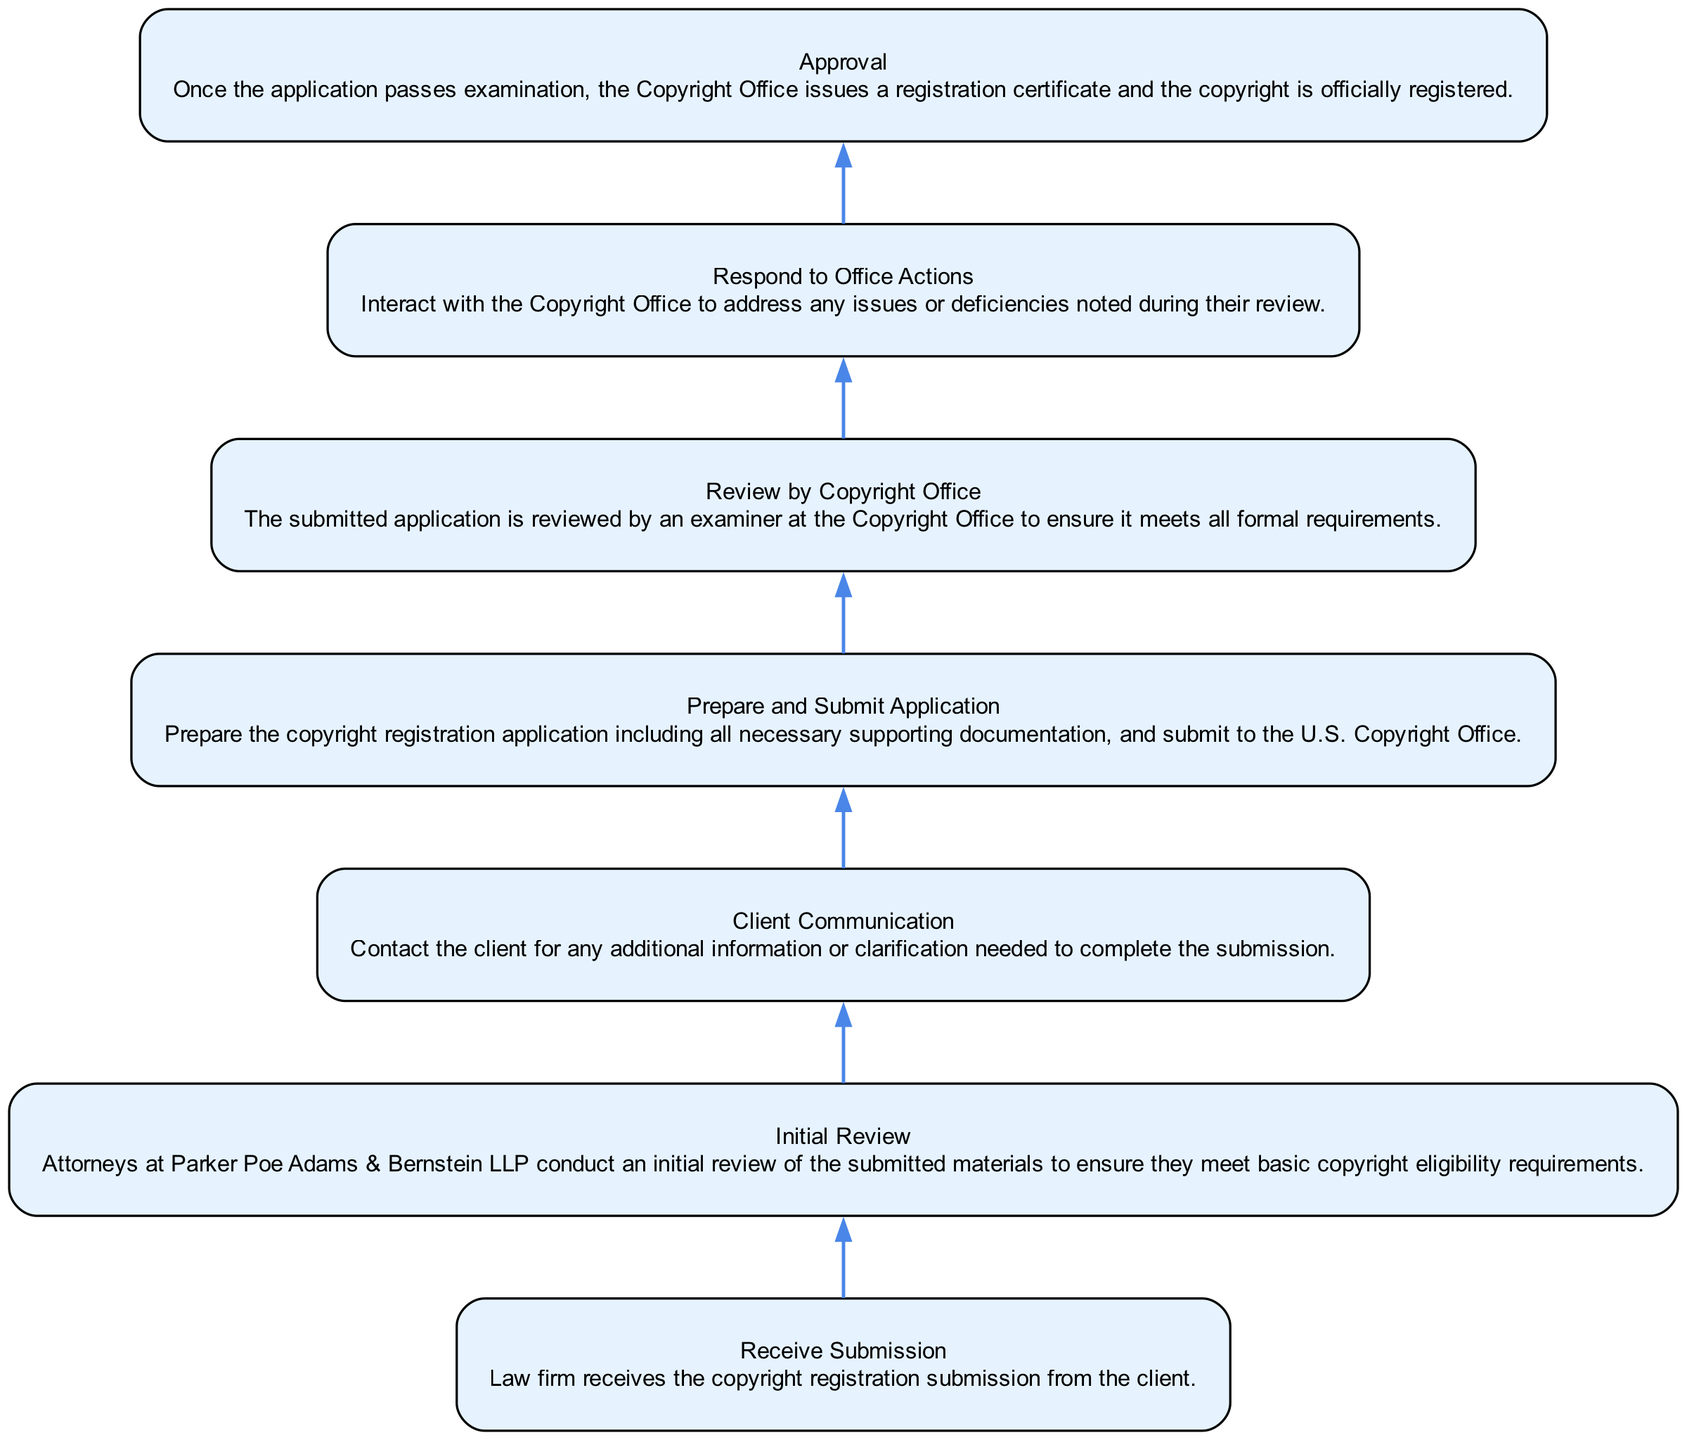What is the first step in the workflow? The first step in the workflow is labeled "Receive Submission" which indicates that the law firm has received the copyright registration submission from the client.
Answer: Receive Submission How many steps are there in the diagram? By counting each distinct step in the workflow, we find there are a total of 7 steps, from "Receive Submission" to "Approval."
Answer: 7 What step comes after "Prepare and Submit Application"? Looking through the flow of the diagram, after "Prepare and Submit Application," the next step is "Review by Copyright Office."
Answer: Review by Copyright Office What is the final outcome of the workflow? The final outcome of the workflow is represented by the last step labeled "Approval," which indicates the copyright has been officially registered.
Answer: Approval Which step involves communication with the client? The step that involves communication with the client is "Client Communication," where the attorneys contact the client for additional information or clarification.
Answer: Client Communication What does the "Respond to Office Actions" step address? The "Respond to Office Actions" step is focused on interacting with the Copyright Office to address issues or deficiencies noted during their review of the application.
Answer: Issues or deficiencies How does the diagram show the progression of the workflow? The diagram displays the progression of the workflow in a bottom-to-top direction, where each step leads sequentially to the next, illustrating the flow of actions from submission to approval.
Answer: Bottom-to-top flow Which step follows "Review by Copyright Office"? Following "Review by Copyright Office," the subsequent step in the workflow is "Respond to Office Actions."
Answer: Respond to Office Actions What kind of document is issued at the end of the workflow? The document issued at the end of the workflow is a "registration certificate," which signifies the official registration of copyright.
Answer: Registration certificate 